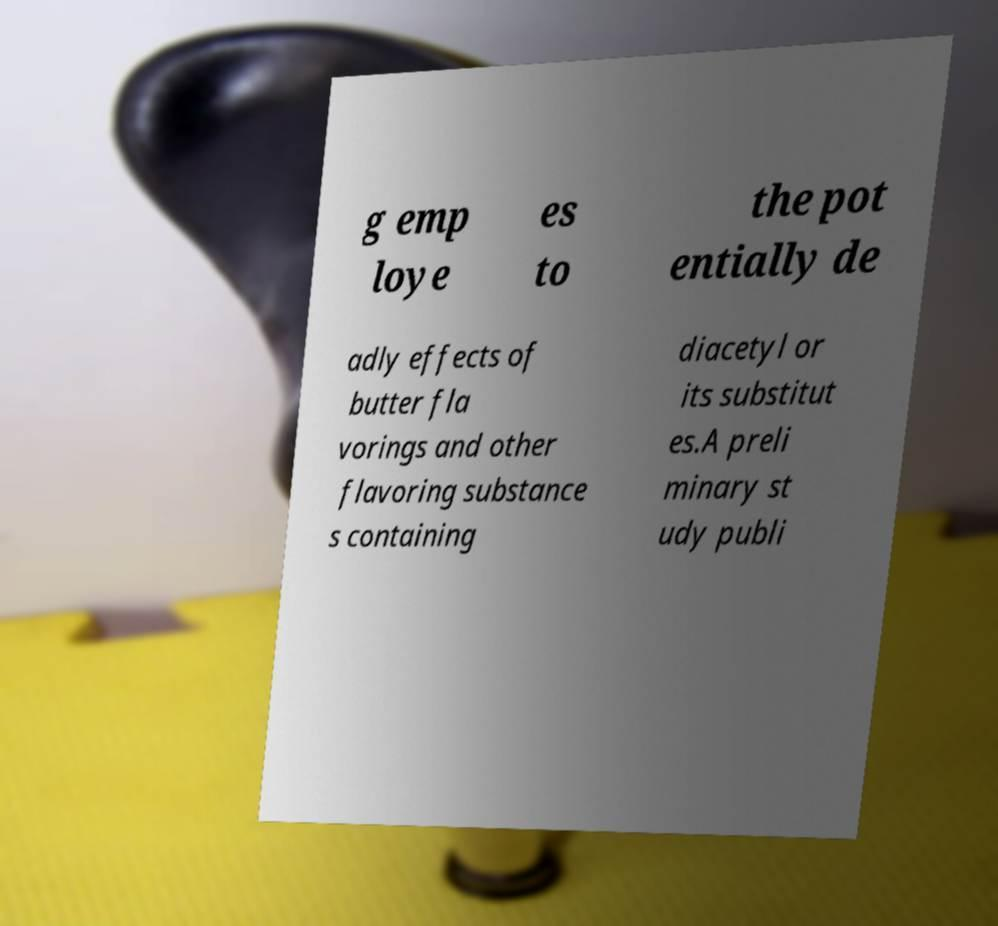There's text embedded in this image that I need extracted. Can you transcribe it verbatim? g emp loye es to the pot entially de adly effects of butter fla vorings and other flavoring substance s containing diacetyl or its substitut es.A preli minary st udy publi 